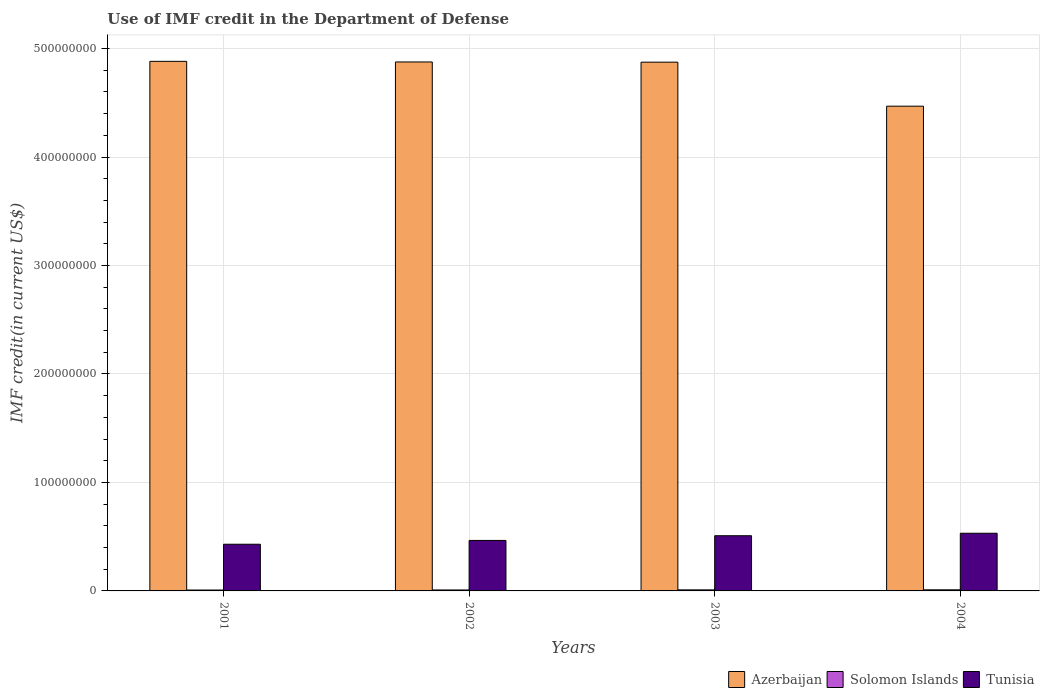Are the number of bars on each tick of the X-axis equal?
Your response must be concise. Yes. How many bars are there on the 4th tick from the left?
Provide a short and direct response. 3. What is the label of the 3rd group of bars from the left?
Your answer should be compact. 2003. What is the IMF credit in the Department of Defense in Tunisia in 2002?
Make the answer very short. 4.66e+07. Across all years, what is the maximum IMF credit in the Department of Defense in Solomon Islands?
Your answer should be compact. 1.02e+06. Across all years, what is the minimum IMF credit in the Department of Defense in Azerbaijan?
Keep it short and to the point. 4.47e+08. What is the total IMF credit in the Department of Defense in Solomon Islands in the graph?
Your response must be concise. 3.70e+06. What is the difference between the IMF credit in the Department of Defense in Azerbaijan in 2001 and that in 2002?
Provide a short and direct response. 5.67e+05. What is the difference between the IMF credit in the Department of Defense in Azerbaijan in 2003 and the IMF credit in the Department of Defense in Solomon Islands in 2001?
Make the answer very short. 4.87e+08. What is the average IMF credit in the Department of Defense in Solomon Islands per year?
Make the answer very short. 9.25e+05. In the year 2001, what is the difference between the IMF credit in the Department of Defense in Azerbaijan and IMF credit in the Department of Defense in Tunisia?
Your answer should be very brief. 4.45e+08. What is the ratio of the IMF credit in the Department of Defense in Solomon Islands in 2001 to that in 2004?
Offer a terse response. 0.81. Is the IMF credit in the Department of Defense in Azerbaijan in 2003 less than that in 2004?
Offer a terse response. No. Is the difference between the IMF credit in the Department of Defense in Azerbaijan in 2002 and 2003 greater than the difference between the IMF credit in the Department of Defense in Tunisia in 2002 and 2003?
Your answer should be very brief. Yes. What is the difference between the highest and the second highest IMF credit in the Department of Defense in Tunisia?
Your response must be concise. 2.30e+06. What is the difference between the highest and the lowest IMF credit in the Department of Defense in Tunisia?
Make the answer very short. 1.01e+07. Is the sum of the IMF credit in the Department of Defense in Azerbaijan in 2001 and 2004 greater than the maximum IMF credit in the Department of Defense in Tunisia across all years?
Give a very brief answer. Yes. What does the 3rd bar from the left in 2004 represents?
Keep it short and to the point. Tunisia. What does the 2nd bar from the right in 2003 represents?
Your answer should be very brief. Solomon Islands. Is it the case that in every year, the sum of the IMF credit in the Department of Defense in Solomon Islands and IMF credit in the Department of Defense in Azerbaijan is greater than the IMF credit in the Department of Defense in Tunisia?
Provide a succinct answer. Yes. Are all the bars in the graph horizontal?
Offer a terse response. No. What is the difference between two consecutive major ticks on the Y-axis?
Keep it short and to the point. 1.00e+08. Does the graph contain any zero values?
Keep it short and to the point. No. Where does the legend appear in the graph?
Keep it short and to the point. Bottom right. How are the legend labels stacked?
Provide a succinct answer. Horizontal. What is the title of the graph?
Make the answer very short. Use of IMF credit in the Department of Defense. Does "High income: nonOECD" appear as one of the legend labels in the graph?
Your response must be concise. No. What is the label or title of the Y-axis?
Give a very brief answer. IMF credit(in current US$). What is the IMF credit(in current US$) of Azerbaijan in 2001?
Your response must be concise. 4.88e+08. What is the IMF credit(in current US$) in Solomon Islands in 2001?
Your answer should be very brief. 8.22e+05. What is the IMF credit(in current US$) of Tunisia in 2001?
Provide a short and direct response. 4.30e+07. What is the IMF credit(in current US$) in Azerbaijan in 2002?
Offer a very short reply. 4.88e+08. What is the IMF credit(in current US$) of Solomon Islands in 2002?
Your response must be concise. 8.90e+05. What is the IMF credit(in current US$) in Tunisia in 2002?
Ensure brevity in your answer.  4.66e+07. What is the IMF credit(in current US$) in Azerbaijan in 2003?
Your answer should be compact. 4.87e+08. What is the IMF credit(in current US$) of Solomon Islands in 2003?
Your answer should be very brief. 9.72e+05. What is the IMF credit(in current US$) in Tunisia in 2003?
Your answer should be compact. 5.09e+07. What is the IMF credit(in current US$) of Azerbaijan in 2004?
Give a very brief answer. 4.47e+08. What is the IMF credit(in current US$) in Solomon Islands in 2004?
Give a very brief answer. 1.02e+06. What is the IMF credit(in current US$) of Tunisia in 2004?
Ensure brevity in your answer.  5.32e+07. Across all years, what is the maximum IMF credit(in current US$) of Azerbaijan?
Keep it short and to the point. 4.88e+08. Across all years, what is the maximum IMF credit(in current US$) in Solomon Islands?
Provide a short and direct response. 1.02e+06. Across all years, what is the maximum IMF credit(in current US$) of Tunisia?
Keep it short and to the point. 5.32e+07. Across all years, what is the minimum IMF credit(in current US$) in Azerbaijan?
Provide a short and direct response. 4.47e+08. Across all years, what is the minimum IMF credit(in current US$) of Solomon Islands?
Ensure brevity in your answer.  8.22e+05. Across all years, what is the minimum IMF credit(in current US$) of Tunisia?
Offer a very short reply. 4.30e+07. What is the total IMF credit(in current US$) in Azerbaijan in the graph?
Make the answer very short. 1.91e+09. What is the total IMF credit(in current US$) in Solomon Islands in the graph?
Keep it short and to the point. 3.70e+06. What is the total IMF credit(in current US$) in Tunisia in the graph?
Make the answer very short. 1.94e+08. What is the difference between the IMF credit(in current US$) in Azerbaijan in 2001 and that in 2002?
Offer a very short reply. 5.67e+05. What is the difference between the IMF credit(in current US$) in Solomon Islands in 2001 and that in 2002?
Offer a terse response. -6.80e+04. What is the difference between the IMF credit(in current US$) of Tunisia in 2001 and that in 2002?
Keep it short and to the point. -3.52e+06. What is the difference between the IMF credit(in current US$) of Azerbaijan in 2001 and that in 2003?
Offer a very short reply. 7.47e+05. What is the difference between the IMF credit(in current US$) of Tunisia in 2001 and that in 2003?
Provide a succinct answer. -7.85e+06. What is the difference between the IMF credit(in current US$) of Azerbaijan in 2001 and that in 2004?
Offer a very short reply. 4.13e+07. What is the difference between the IMF credit(in current US$) of Solomon Islands in 2001 and that in 2004?
Ensure brevity in your answer.  -1.94e+05. What is the difference between the IMF credit(in current US$) of Tunisia in 2001 and that in 2004?
Give a very brief answer. -1.01e+07. What is the difference between the IMF credit(in current US$) of Solomon Islands in 2002 and that in 2003?
Offer a terse response. -8.20e+04. What is the difference between the IMF credit(in current US$) of Tunisia in 2002 and that in 2003?
Make the answer very short. -4.33e+06. What is the difference between the IMF credit(in current US$) in Azerbaijan in 2002 and that in 2004?
Keep it short and to the point. 4.08e+07. What is the difference between the IMF credit(in current US$) of Solomon Islands in 2002 and that in 2004?
Your answer should be very brief. -1.26e+05. What is the difference between the IMF credit(in current US$) in Tunisia in 2002 and that in 2004?
Your response must be concise. -6.63e+06. What is the difference between the IMF credit(in current US$) of Azerbaijan in 2003 and that in 2004?
Provide a succinct answer. 4.06e+07. What is the difference between the IMF credit(in current US$) in Solomon Islands in 2003 and that in 2004?
Offer a very short reply. -4.40e+04. What is the difference between the IMF credit(in current US$) of Tunisia in 2003 and that in 2004?
Provide a short and direct response. -2.30e+06. What is the difference between the IMF credit(in current US$) in Azerbaijan in 2001 and the IMF credit(in current US$) in Solomon Islands in 2002?
Make the answer very short. 4.87e+08. What is the difference between the IMF credit(in current US$) of Azerbaijan in 2001 and the IMF credit(in current US$) of Tunisia in 2002?
Give a very brief answer. 4.42e+08. What is the difference between the IMF credit(in current US$) of Solomon Islands in 2001 and the IMF credit(in current US$) of Tunisia in 2002?
Ensure brevity in your answer.  -4.57e+07. What is the difference between the IMF credit(in current US$) in Azerbaijan in 2001 and the IMF credit(in current US$) in Solomon Islands in 2003?
Offer a very short reply. 4.87e+08. What is the difference between the IMF credit(in current US$) of Azerbaijan in 2001 and the IMF credit(in current US$) of Tunisia in 2003?
Your response must be concise. 4.37e+08. What is the difference between the IMF credit(in current US$) in Solomon Islands in 2001 and the IMF credit(in current US$) in Tunisia in 2003?
Your answer should be very brief. -5.01e+07. What is the difference between the IMF credit(in current US$) of Azerbaijan in 2001 and the IMF credit(in current US$) of Solomon Islands in 2004?
Give a very brief answer. 4.87e+08. What is the difference between the IMF credit(in current US$) of Azerbaijan in 2001 and the IMF credit(in current US$) of Tunisia in 2004?
Your answer should be compact. 4.35e+08. What is the difference between the IMF credit(in current US$) in Solomon Islands in 2001 and the IMF credit(in current US$) in Tunisia in 2004?
Offer a very short reply. -5.24e+07. What is the difference between the IMF credit(in current US$) in Azerbaijan in 2002 and the IMF credit(in current US$) in Solomon Islands in 2003?
Keep it short and to the point. 4.87e+08. What is the difference between the IMF credit(in current US$) in Azerbaijan in 2002 and the IMF credit(in current US$) in Tunisia in 2003?
Your answer should be very brief. 4.37e+08. What is the difference between the IMF credit(in current US$) of Solomon Islands in 2002 and the IMF credit(in current US$) of Tunisia in 2003?
Offer a very short reply. -5.00e+07. What is the difference between the IMF credit(in current US$) of Azerbaijan in 2002 and the IMF credit(in current US$) of Solomon Islands in 2004?
Ensure brevity in your answer.  4.87e+08. What is the difference between the IMF credit(in current US$) of Azerbaijan in 2002 and the IMF credit(in current US$) of Tunisia in 2004?
Provide a short and direct response. 4.34e+08. What is the difference between the IMF credit(in current US$) of Solomon Islands in 2002 and the IMF credit(in current US$) of Tunisia in 2004?
Keep it short and to the point. -5.23e+07. What is the difference between the IMF credit(in current US$) in Azerbaijan in 2003 and the IMF credit(in current US$) in Solomon Islands in 2004?
Keep it short and to the point. 4.86e+08. What is the difference between the IMF credit(in current US$) in Azerbaijan in 2003 and the IMF credit(in current US$) in Tunisia in 2004?
Offer a very short reply. 4.34e+08. What is the difference between the IMF credit(in current US$) of Solomon Islands in 2003 and the IMF credit(in current US$) of Tunisia in 2004?
Your response must be concise. -5.22e+07. What is the average IMF credit(in current US$) in Azerbaijan per year?
Provide a short and direct response. 4.78e+08. What is the average IMF credit(in current US$) of Solomon Islands per year?
Ensure brevity in your answer.  9.25e+05. What is the average IMF credit(in current US$) in Tunisia per year?
Your answer should be very brief. 4.84e+07. In the year 2001, what is the difference between the IMF credit(in current US$) in Azerbaijan and IMF credit(in current US$) in Solomon Islands?
Your answer should be very brief. 4.87e+08. In the year 2001, what is the difference between the IMF credit(in current US$) of Azerbaijan and IMF credit(in current US$) of Tunisia?
Keep it short and to the point. 4.45e+08. In the year 2001, what is the difference between the IMF credit(in current US$) of Solomon Islands and IMF credit(in current US$) of Tunisia?
Your answer should be very brief. -4.22e+07. In the year 2002, what is the difference between the IMF credit(in current US$) in Azerbaijan and IMF credit(in current US$) in Solomon Islands?
Provide a short and direct response. 4.87e+08. In the year 2002, what is the difference between the IMF credit(in current US$) in Azerbaijan and IMF credit(in current US$) in Tunisia?
Give a very brief answer. 4.41e+08. In the year 2002, what is the difference between the IMF credit(in current US$) of Solomon Islands and IMF credit(in current US$) of Tunisia?
Your answer should be compact. -4.57e+07. In the year 2003, what is the difference between the IMF credit(in current US$) in Azerbaijan and IMF credit(in current US$) in Solomon Islands?
Your answer should be compact. 4.86e+08. In the year 2003, what is the difference between the IMF credit(in current US$) in Azerbaijan and IMF credit(in current US$) in Tunisia?
Provide a short and direct response. 4.37e+08. In the year 2003, what is the difference between the IMF credit(in current US$) of Solomon Islands and IMF credit(in current US$) of Tunisia?
Ensure brevity in your answer.  -4.99e+07. In the year 2004, what is the difference between the IMF credit(in current US$) in Azerbaijan and IMF credit(in current US$) in Solomon Islands?
Ensure brevity in your answer.  4.46e+08. In the year 2004, what is the difference between the IMF credit(in current US$) of Azerbaijan and IMF credit(in current US$) of Tunisia?
Make the answer very short. 3.94e+08. In the year 2004, what is the difference between the IMF credit(in current US$) in Solomon Islands and IMF credit(in current US$) in Tunisia?
Keep it short and to the point. -5.22e+07. What is the ratio of the IMF credit(in current US$) in Solomon Islands in 2001 to that in 2002?
Provide a succinct answer. 0.92. What is the ratio of the IMF credit(in current US$) in Tunisia in 2001 to that in 2002?
Offer a very short reply. 0.92. What is the ratio of the IMF credit(in current US$) in Solomon Islands in 2001 to that in 2003?
Provide a succinct answer. 0.85. What is the ratio of the IMF credit(in current US$) in Tunisia in 2001 to that in 2003?
Offer a terse response. 0.85. What is the ratio of the IMF credit(in current US$) in Azerbaijan in 2001 to that in 2004?
Your response must be concise. 1.09. What is the ratio of the IMF credit(in current US$) in Solomon Islands in 2001 to that in 2004?
Keep it short and to the point. 0.81. What is the ratio of the IMF credit(in current US$) in Tunisia in 2001 to that in 2004?
Give a very brief answer. 0.81. What is the ratio of the IMF credit(in current US$) of Solomon Islands in 2002 to that in 2003?
Provide a short and direct response. 0.92. What is the ratio of the IMF credit(in current US$) of Tunisia in 2002 to that in 2003?
Make the answer very short. 0.91. What is the ratio of the IMF credit(in current US$) of Azerbaijan in 2002 to that in 2004?
Offer a terse response. 1.09. What is the ratio of the IMF credit(in current US$) in Solomon Islands in 2002 to that in 2004?
Your answer should be compact. 0.88. What is the ratio of the IMF credit(in current US$) in Tunisia in 2002 to that in 2004?
Your response must be concise. 0.88. What is the ratio of the IMF credit(in current US$) of Azerbaijan in 2003 to that in 2004?
Keep it short and to the point. 1.09. What is the ratio of the IMF credit(in current US$) in Solomon Islands in 2003 to that in 2004?
Your answer should be compact. 0.96. What is the ratio of the IMF credit(in current US$) of Tunisia in 2003 to that in 2004?
Make the answer very short. 0.96. What is the difference between the highest and the second highest IMF credit(in current US$) in Azerbaijan?
Offer a terse response. 5.67e+05. What is the difference between the highest and the second highest IMF credit(in current US$) in Solomon Islands?
Offer a terse response. 4.40e+04. What is the difference between the highest and the second highest IMF credit(in current US$) in Tunisia?
Offer a very short reply. 2.30e+06. What is the difference between the highest and the lowest IMF credit(in current US$) in Azerbaijan?
Offer a terse response. 4.13e+07. What is the difference between the highest and the lowest IMF credit(in current US$) in Solomon Islands?
Keep it short and to the point. 1.94e+05. What is the difference between the highest and the lowest IMF credit(in current US$) of Tunisia?
Offer a terse response. 1.01e+07. 